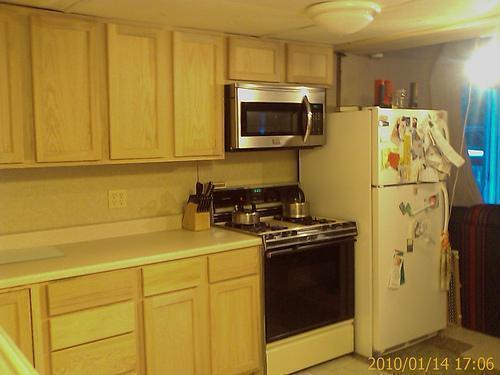What household food might you find in the object on the right?
Indicate the correct response and explain using: 'Answer: answer
Rationale: rationale.'
Options: Tinned fruit, peanuts, potato chips, milk. Answer: milk.
Rationale: Best appliances purpose is to keep food cold this type of liquid is one that needs to be kept at a cooler temperature so that it does not spoil.  placing it in a warm environment such as the countertop would result in rotting. 